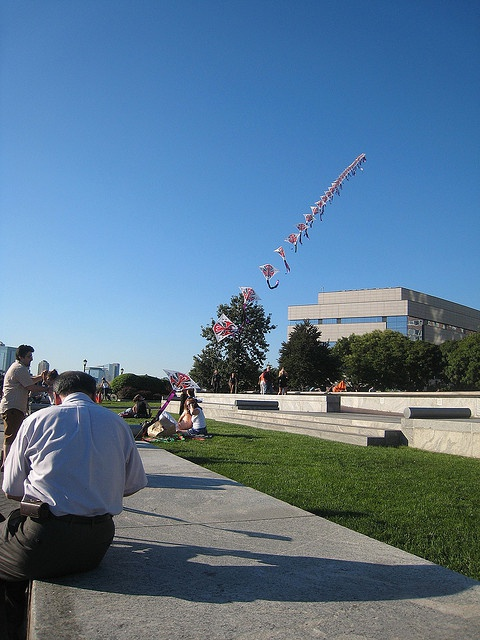Describe the objects in this image and their specific colors. I can see people in gray, black, darkblue, and lightgray tones, people in gray, black, and lightgray tones, people in gray, black, and lightgray tones, kite in gray, darkgray, and purple tones, and kite in gray, lavender, black, and darkgray tones in this image. 